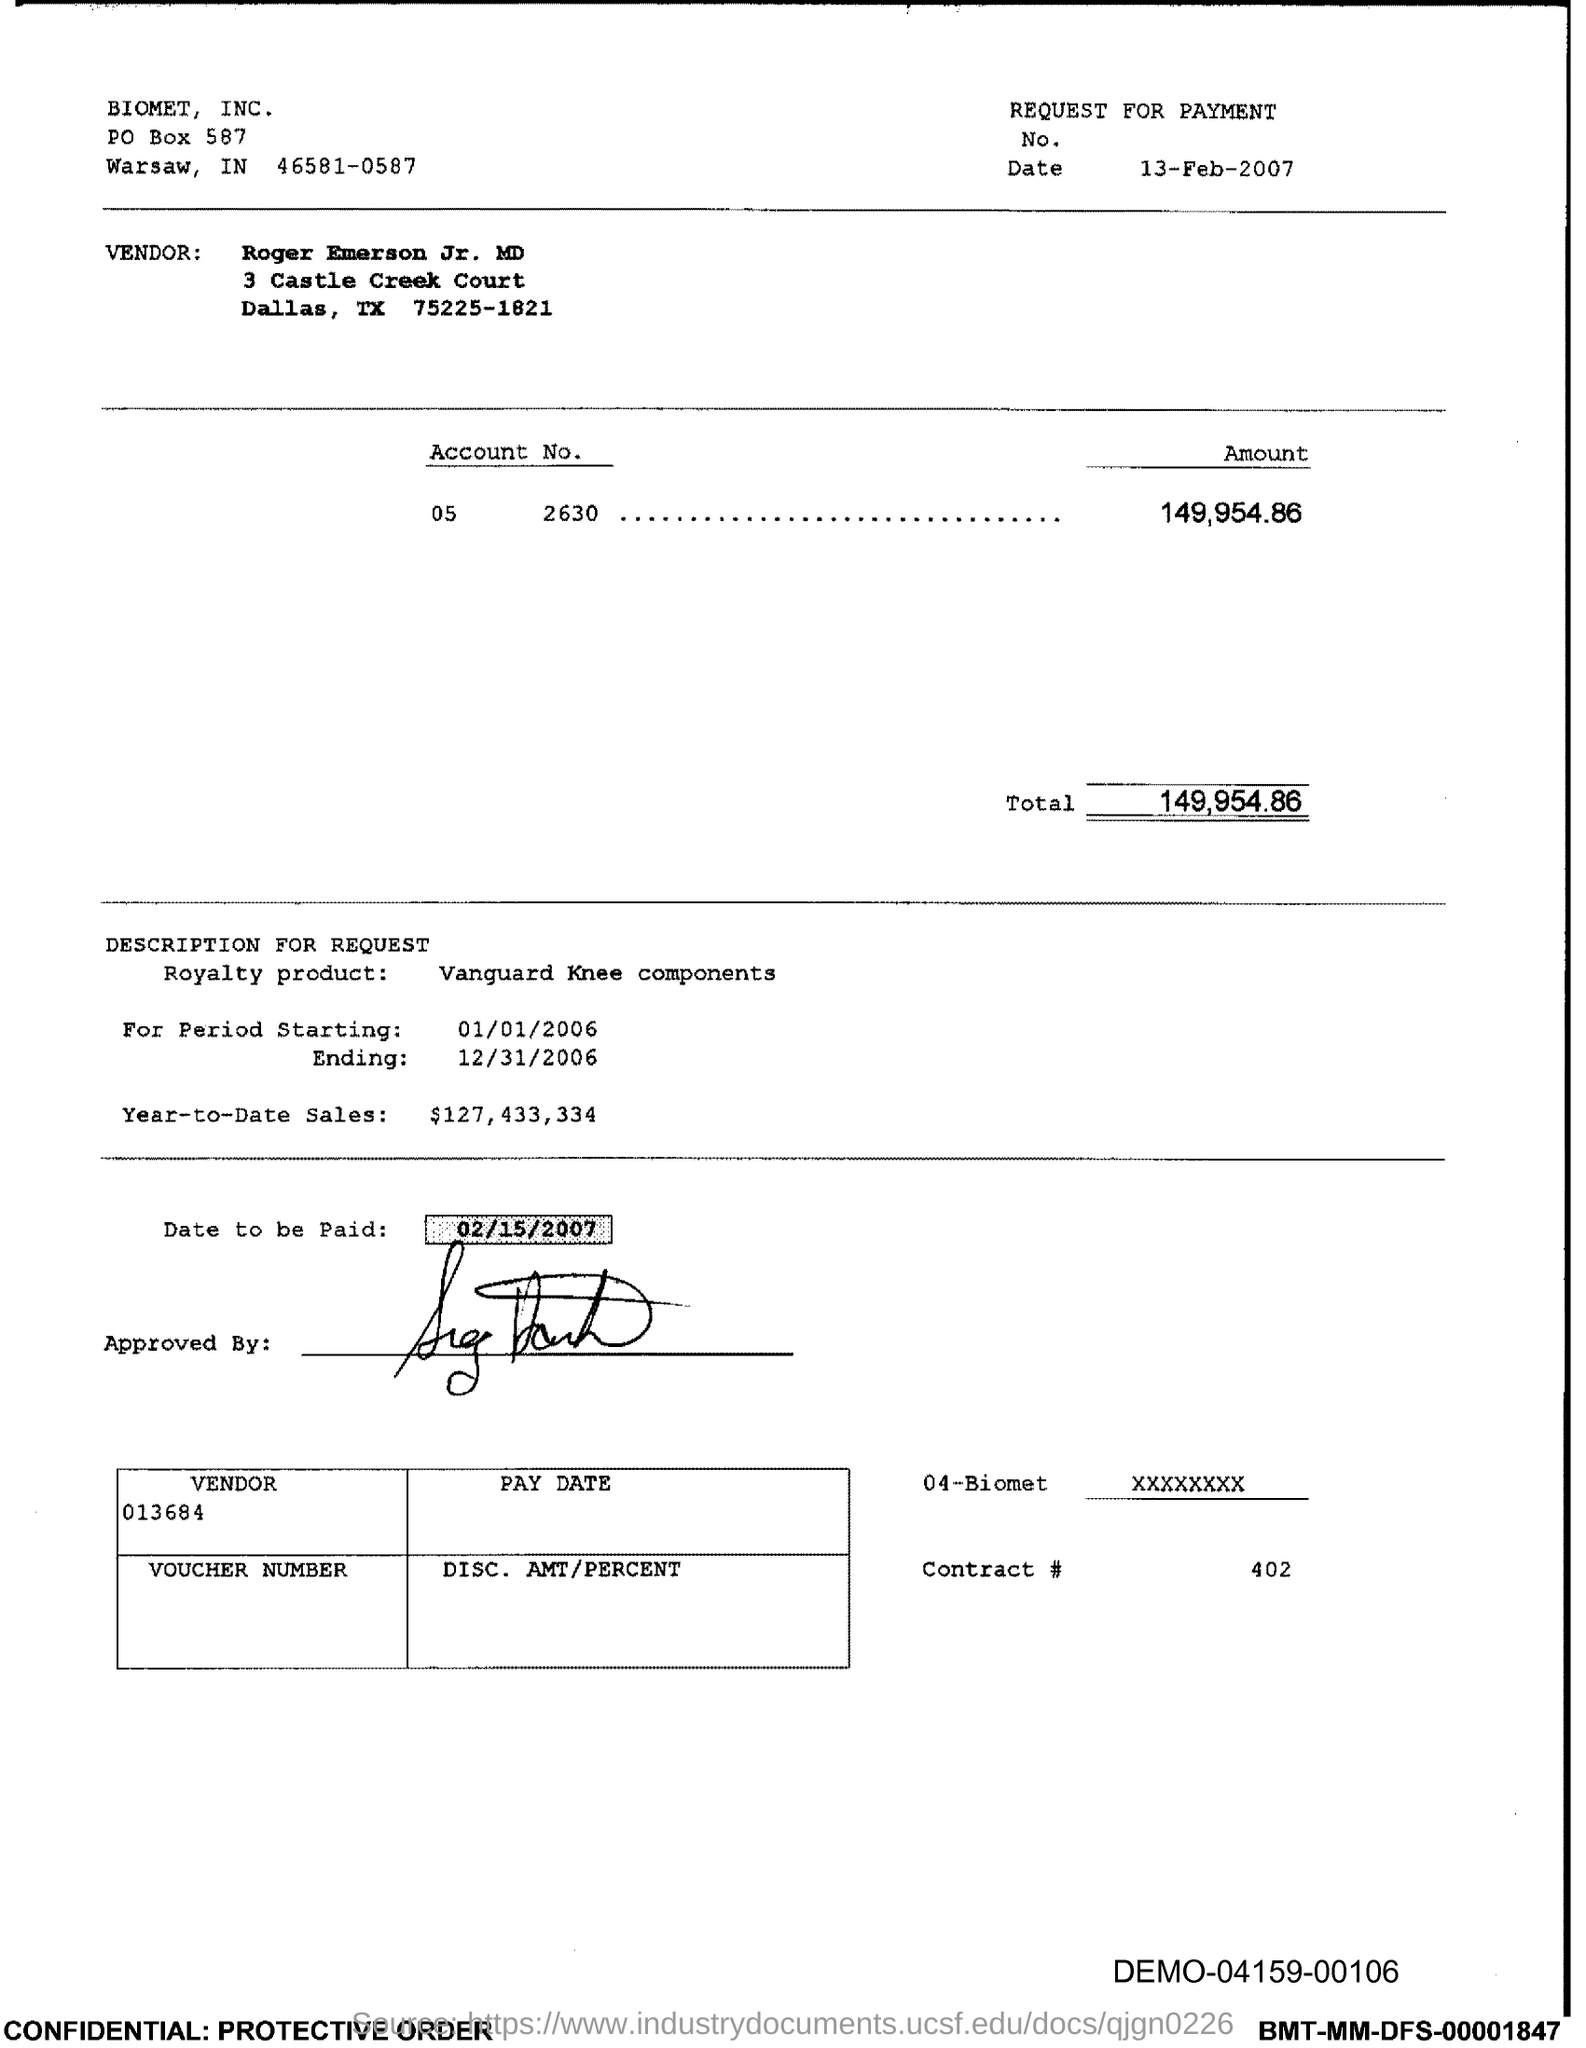List a handful of essential elements in this visual. The total amount is 149,954.86. 